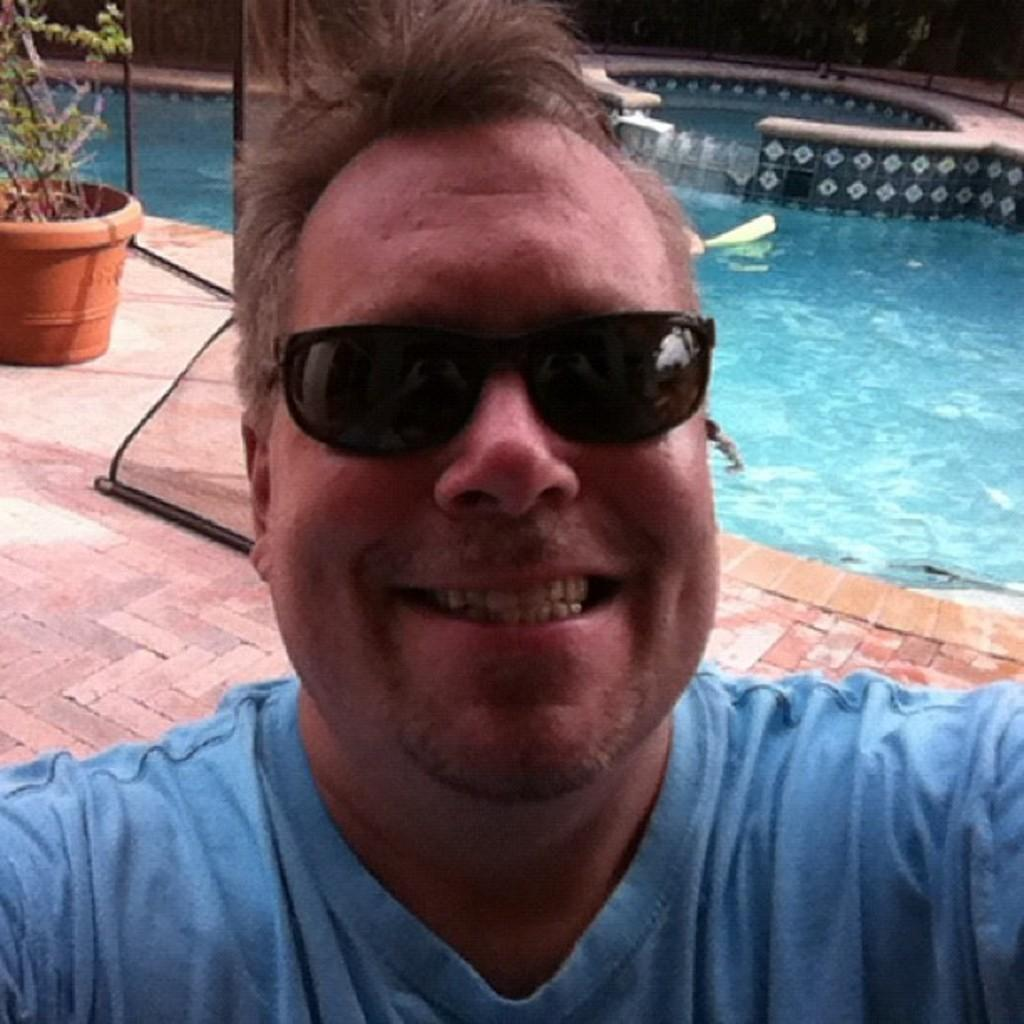Who is present in the image? There is a man in the image. What is the man wearing on his face? The man is wearing goggles. What color is the man's shirt? The man is wearing a blue shirt. What can be seen in the background of the image? There is a swimming pool and a potted plant with water in the background of the image. What type of skin condition does the man have in the image? There is no indication of a skin condition in the image; the man is wearing a blue shirt and goggles. 